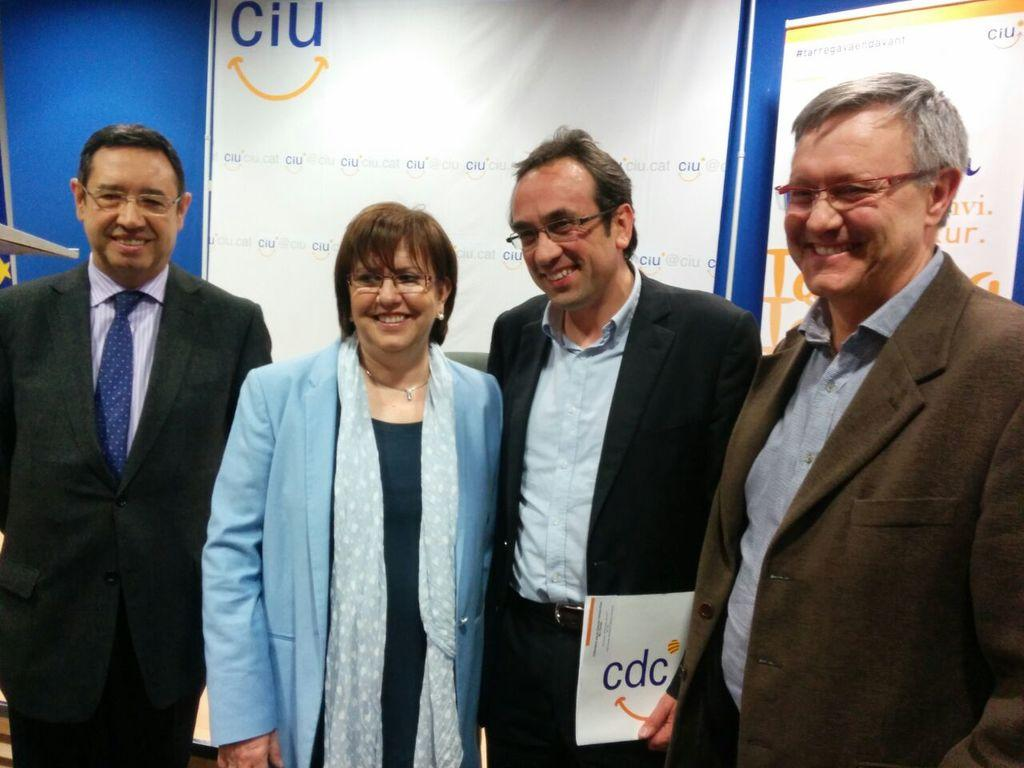How many people are in the image? There are three men and a woman in the image, making a total of four people. What are the individuals in the image doing? The individuals are standing in the front, smiling, and posing for the camera. What can be seen in the background of the image? There are white color banners on a blue wall in the background. Can you tell me how tall the tree is in the image? There is no tree present in the image; it features four individuals standing in front of a blue wall with white banners. 